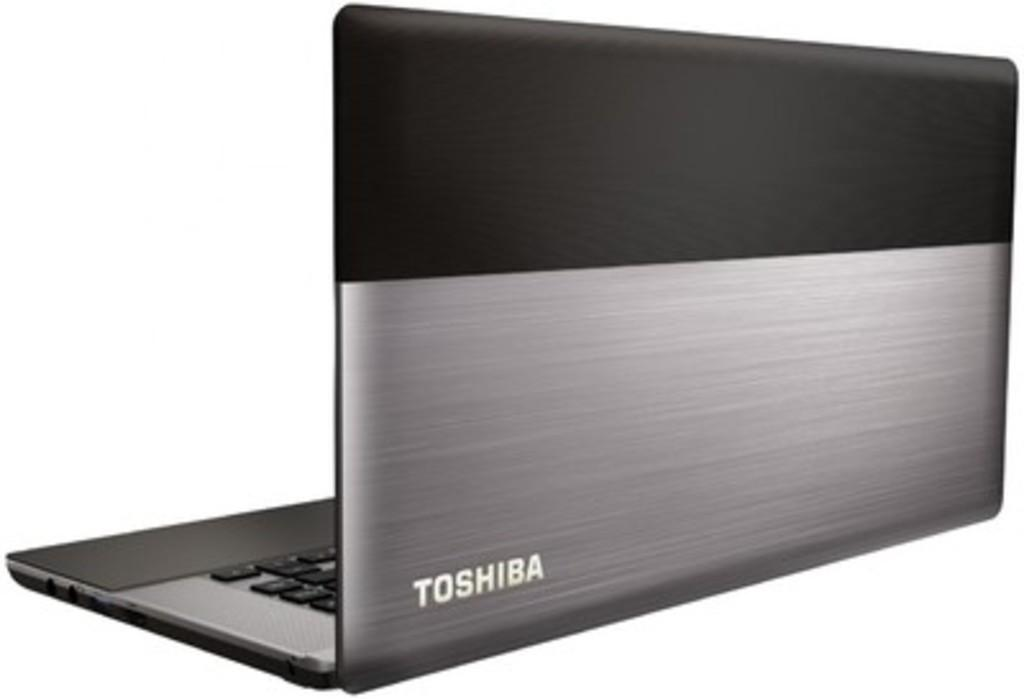What electronic device is visible in the image? There is a laptop in the image. What might someone be using the laptop for? It is not possible to determine the specific use of the laptop from the image alone. Can you describe the appearance of the laptop? The image only shows the laptop, so no specific details about its appearance can be provided. What type of cake is being served by the fairies in the image? There are no fairies or cake present in the image; it only features a laptop. 